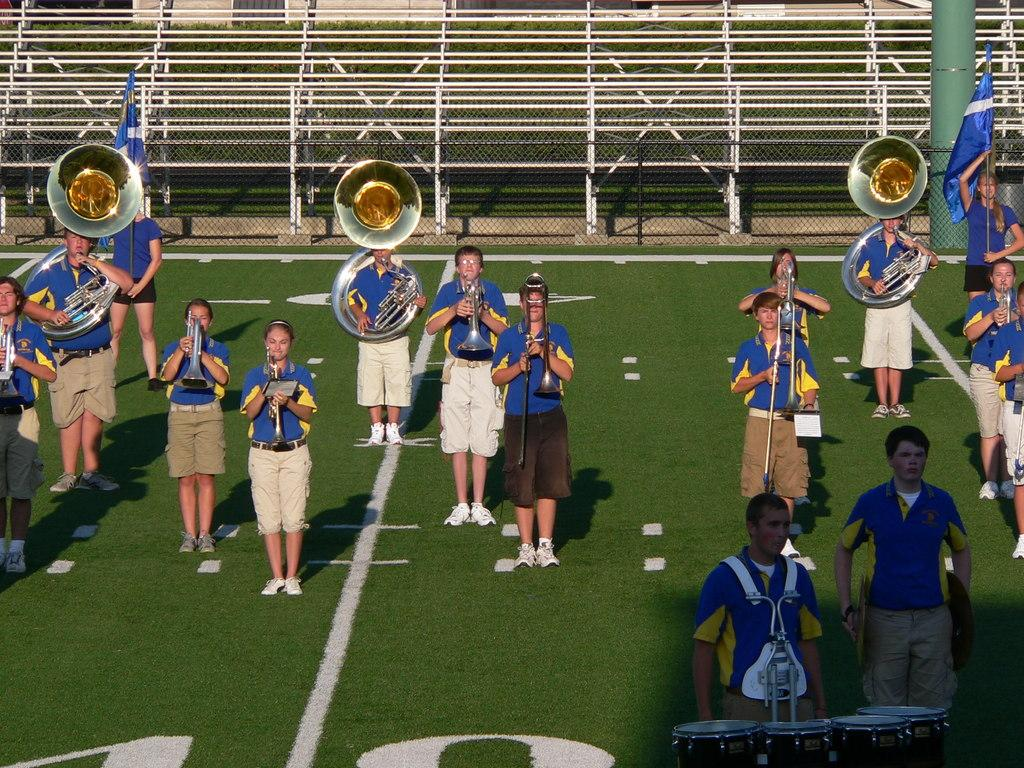What are the people in the image doing? The people in the image are standing and playing musical instruments. Can you describe the woman in the image? The woman is holding a blue color flag on the right side of the image. What type of insurance policy does the woman holding the blue color flag have? There is no information about insurance policies in the image, as it focuses on the group of people playing musical instruments and the woman holding the flag. 